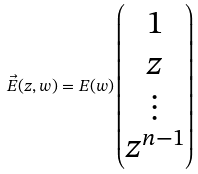<formula> <loc_0><loc_0><loc_500><loc_500>\vec { E } ( z , w ) = E ( w ) \begin{pmatrix} 1 \\ z \\ \vdots \\ z ^ { n - 1 } \end{pmatrix}</formula> 